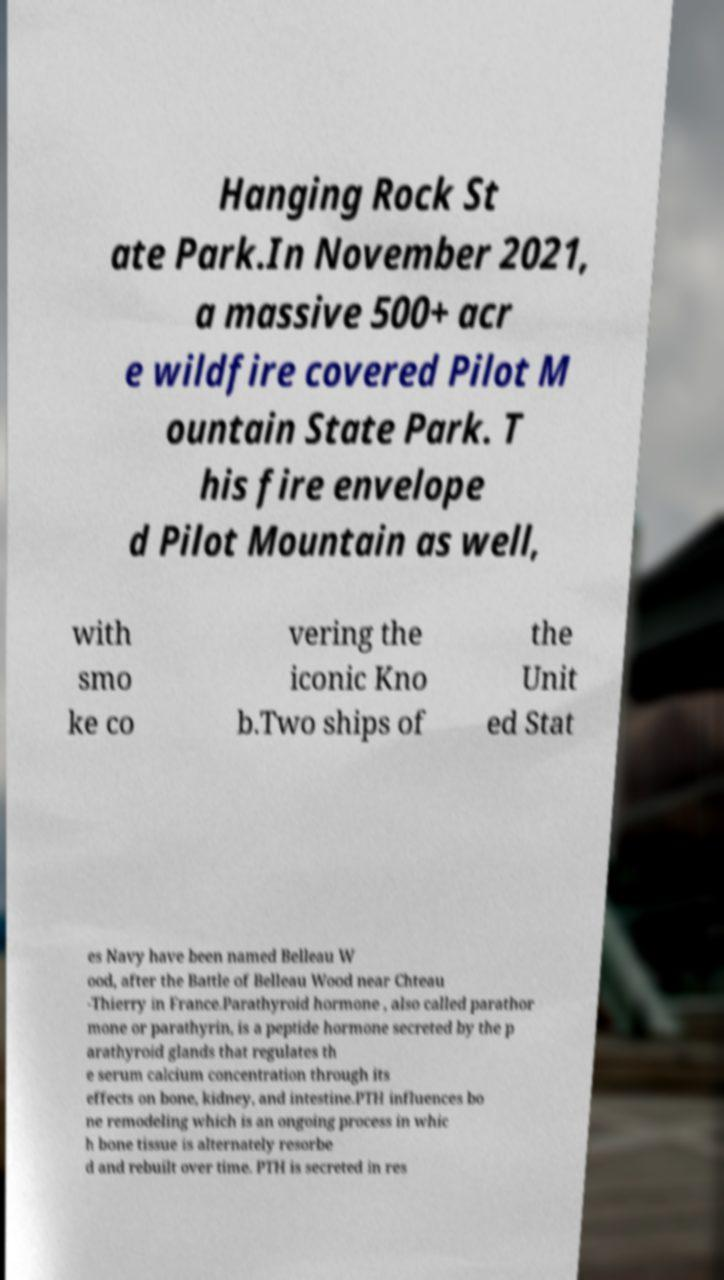Could you extract and type out the text from this image? Hanging Rock St ate Park.In November 2021, a massive 500+ acr e wildfire covered Pilot M ountain State Park. T his fire envelope d Pilot Mountain as well, with smo ke co vering the iconic Kno b.Two ships of the Unit ed Stat es Navy have been named Belleau W ood, after the Battle of Belleau Wood near Chteau -Thierry in France.Parathyroid hormone , also called parathor mone or parathyrin, is a peptide hormone secreted by the p arathyroid glands that regulates th e serum calcium concentration through its effects on bone, kidney, and intestine.PTH influences bo ne remodeling which is an ongoing process in whic h bone tissue is alternately resorbe d and rebuilt over time. PTH is secreted in res 